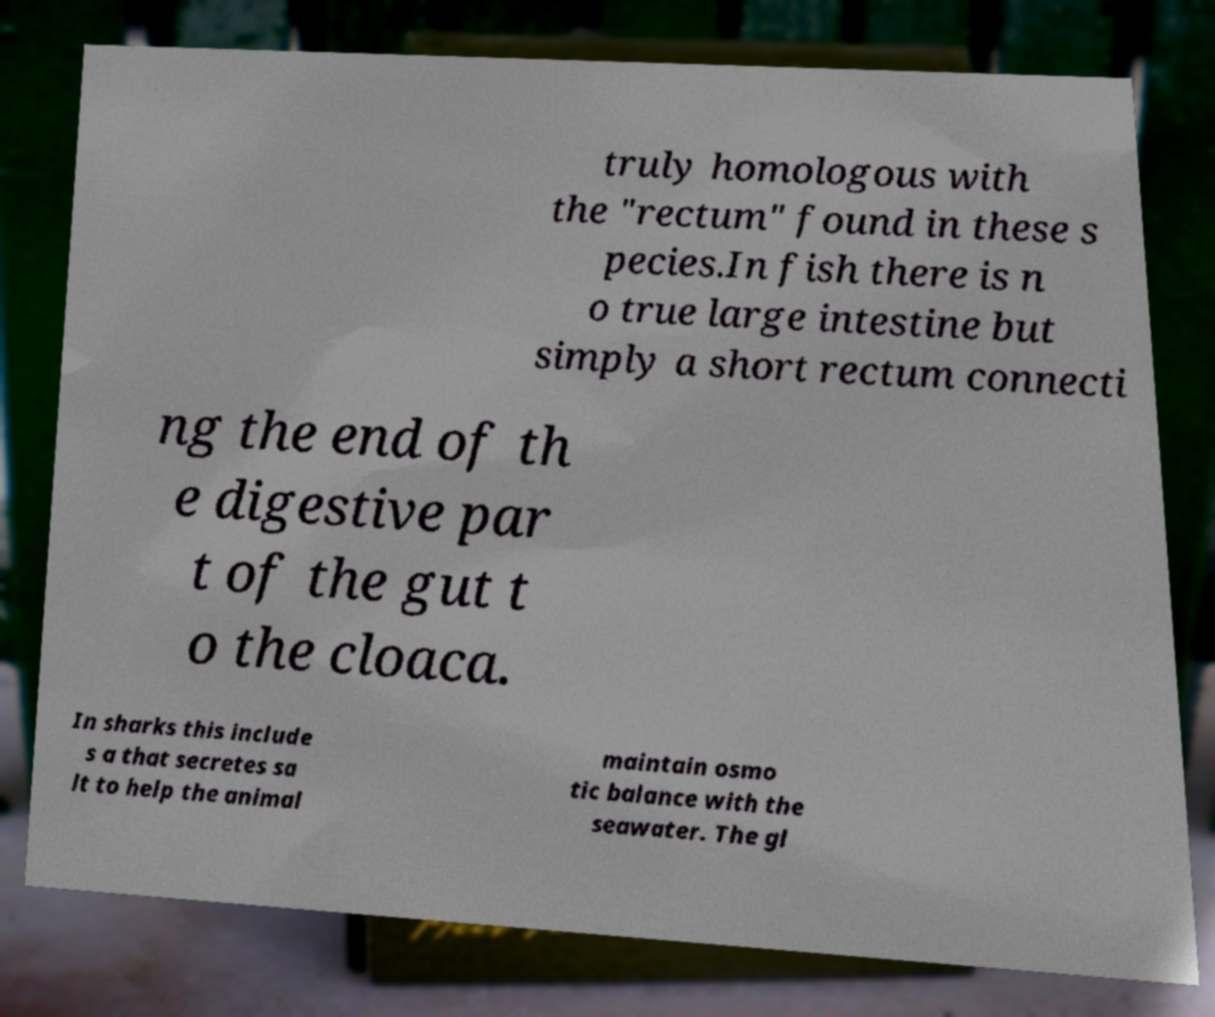I need the written content from this picture converted into text. Can you do that? truly homologous with the "rectum" found in these s pecies.In fish there is n o true large intestine but simply a short rectum connecti ng the end of th e digestive par t of the gut t o the cloaca. In sharks this include s a that secretes sa lt to help the animal maintain osmo tic balance with the seawater. The gl 